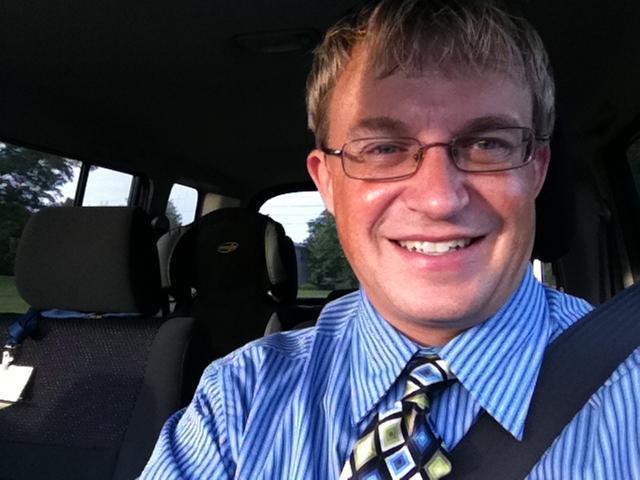How many yellow umbrellas are in this photo?
Give a very brief answer. 0. 